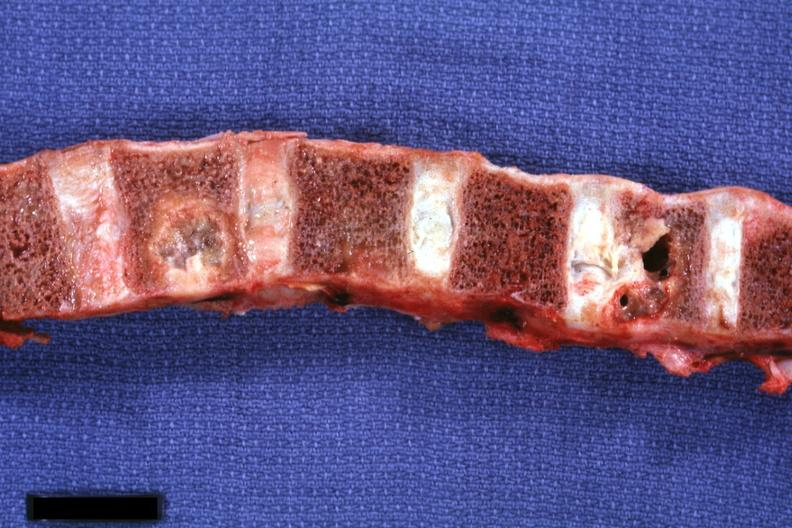how is vertebral bodies showing very nicely osteolytic lesions primary squamous cell carcinoma penis?
Answer the question using a single word or phrase. Metastatic 